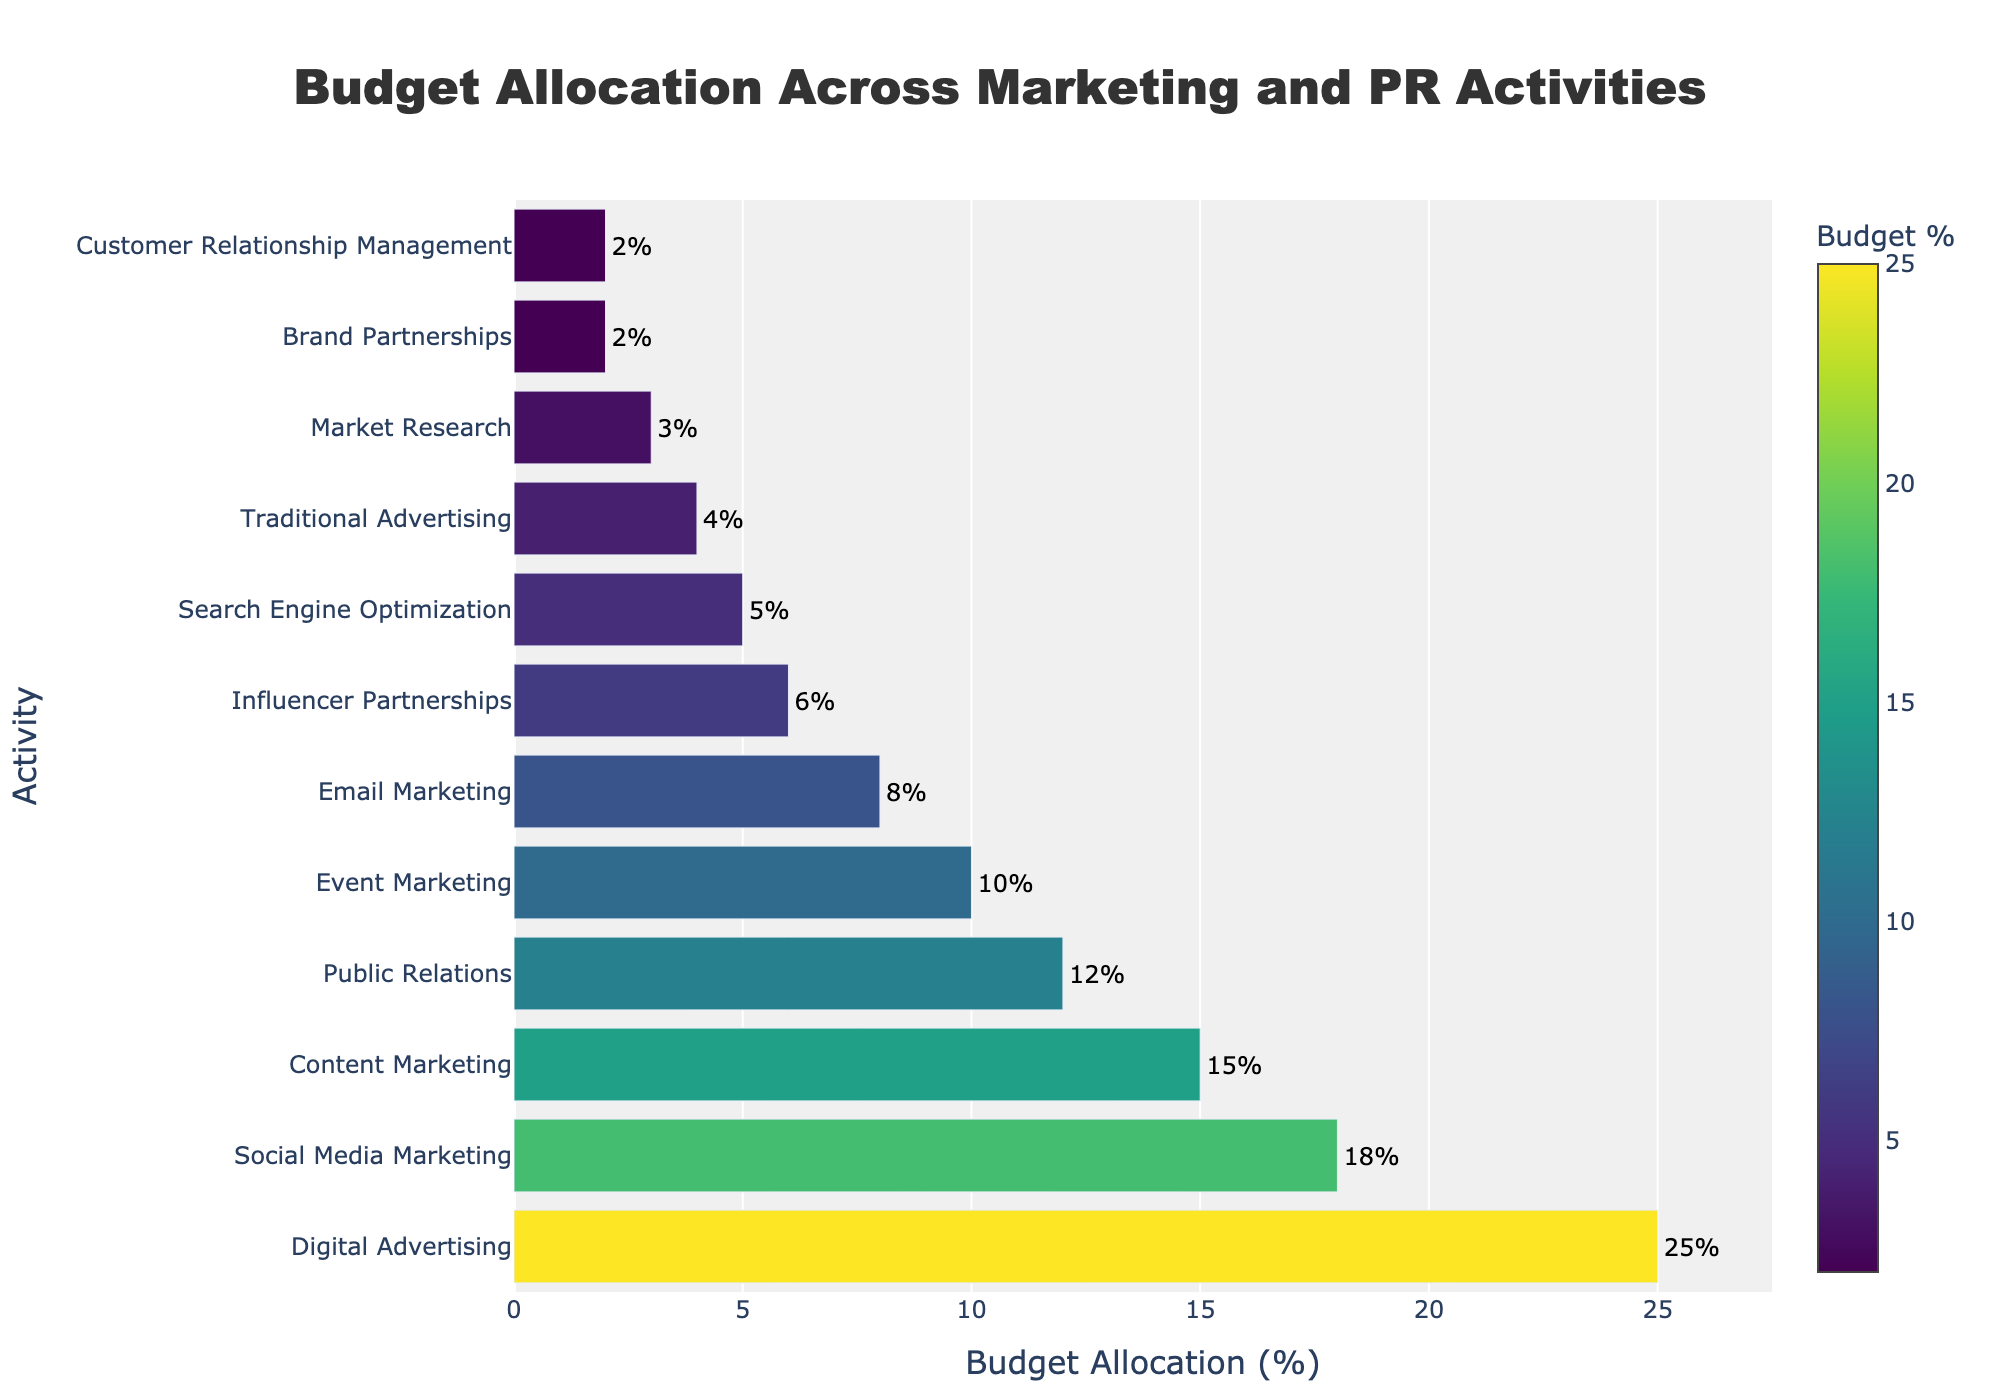What are the three activities with the highest budget allocation? The three activities with the highest budget allocation are the ones with the tallest bars in the figure. By inspecting the figure, the three activities with the highest budget allocation are Digital Advertising, Social Media Marketing, and Content Marketing.
Answer: Digital Advertising, Social Media Marketing, Content Marketing Which activity has the lowest budget allocation? The activity with the shortest bar in the figure represents the lowest budget allocation. By inspecting the bars, Brand Partnerships and Customer Relationship Management have the shortest bars, representing the lowest budget allocation.
Answer: Brand Partnerships, Customer Relationship Management What is the combined budget allocation for Social Media Marketing and Public Relations? To find the combined budget allocation, sum the percentages of Social Media Marketing and Public Relations. From the figure, Social Media Marketing has 18% and Public Relations has 12%. Therefore, 18% + 12% = 30%.
Answer: 30% Is the budget allocation for Event Marketing greater than, less than, or equal to that for Email Marketing? Compare the lengths of the bars for Event Marketing and Email Marketing in the figure. Event Marketing has a taller bar (10%) compared to Email Marketing (8%), so the budget allocation for Event Marketing is greater.
Answer: Greater Which activities have a budget allocation of less than 5%? The activities with budget allocations less than 5% are represented by the bars shorter than 5%. By inspecting the figure, these activities are Search Engine Optimization, Traditional Advertising, Market Research, Brand Partnerships, and Customer Relationship Management.
Answer: Search Engine Optimization, Traditional Advertising, Market Research, Brand Partnerships, Customer Relationship Management What is the difference in budget allocation between Influencer Partnerships and Traditional Advertising? To find the difference, subtract the budget allocation of Traditional Advertising from Influencer Partnerships. From the chart, Influencer Partnerships is 6% and Traditional Advertising is 4%. Therefore, 6% - 4% = 2%.
Answer: 2% What is the average budget allocation for Content Marketing, Public Relations, and Email Marketing? To calculate the average budget allocation, sum the percentages for Content Marketing, Public Relations, and Email Marketing, and then divide by the number of activities. From the chart, Content Marketing is 15%, Public Relations is 12%, and Email Marketing is 8%. The sum is 15% + 12% + 8% = 35%. The average is 35% / 3 = 11.67%.
Answer: 11.67% Which activity has a slightly higher budget allocation than Search Engine Optimization? Look at the bar representing Search Engine Optimization and then find the bar just slightly taller. Search Engine Optimization has a 5% allocation, and the next higher allocation is Influencer Partnerships at 6%.
Answer: Influencer Partnerships How much more budget is allocated to Digital Advertising compared to Market Research? To find how much more budget Digital Advertising has compared to Market Research, subtract the budget allocation for Market Research from Digital Advertising. From the chart, Digital Advertising is 25% and Market Research is 3%. Therefore, 25% - 3% = 22%.
Answer: 22% What is the color of the bar representing Social Media Marketing? The colors in the figure correspond with the budget allocation percentages and use the Viridis colorscale. The Social Media Marketing bar is around the middle range of the colorscale, appearing as a specific shade of green. Therefore, the bar for Social Media Marketing is green.
Answer: Green 